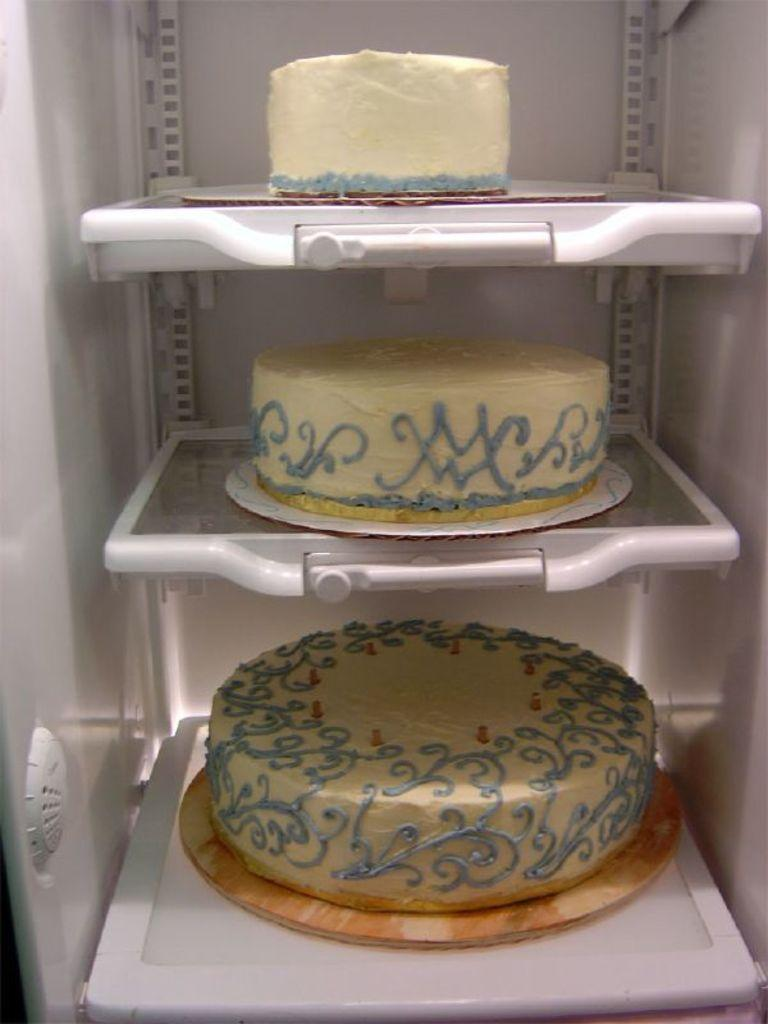How many cakes are visible in the image? There are three cakes in the image. Where are the cakes located? The cakes are in a refrigerator. Reasoning: Let's think step in order to produce the conversation. We start by identifying the main subject in the image, which is the three cakes. Then, we describe the location of the cakes, which is in a refrigerator. Each question is designed to elicit a specific detail about the image that is known from the provided facts. Absurd Question/Answer: What type of pen is used to write on the cakes in the image? There are no pens or writing on the cakes in the image. Are there any boats visible in the image? No, there are no boats present in the image. What is the profit margin for the cakes in the image? There is no information about profit margins in the image, as it only shows three cakes in a refrigerator. 